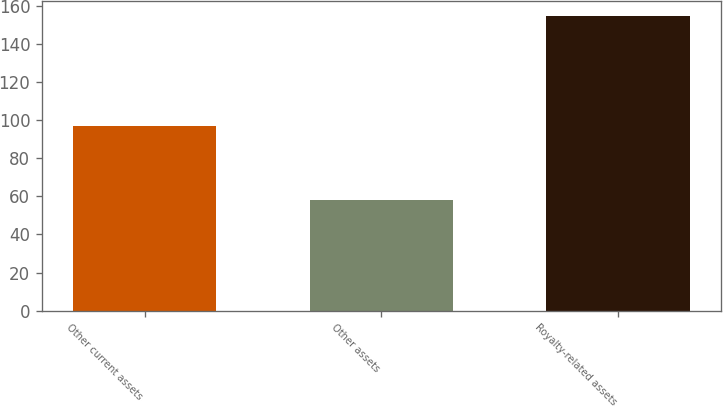<chart> <loc_0><loc_0><loc_500><loc_500><bar_chart><fcel>Other current assets<fcel>Other assets<fcel>Royalty-related assets<nl><fcel>97<fcel>58<fcel>155<nl></chart> 